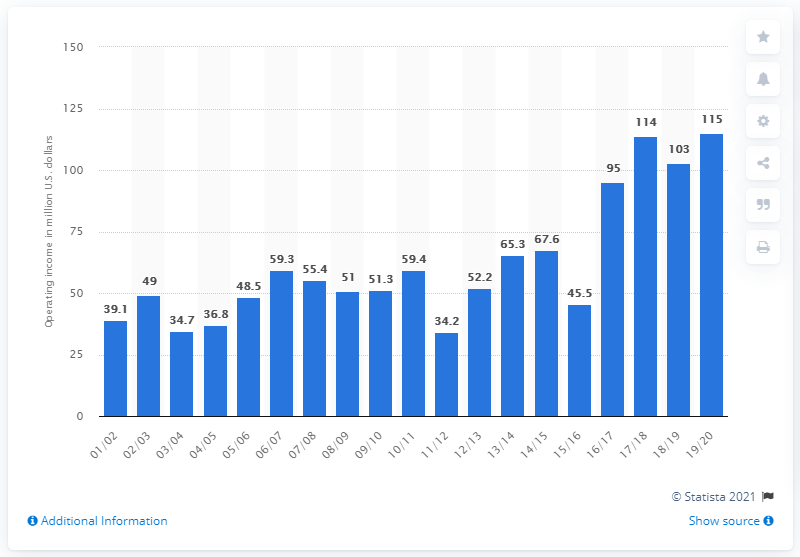Give some essential details in this illustration. The operating income of the Chicago Bulls in the 2019/20 season was $115 million. 